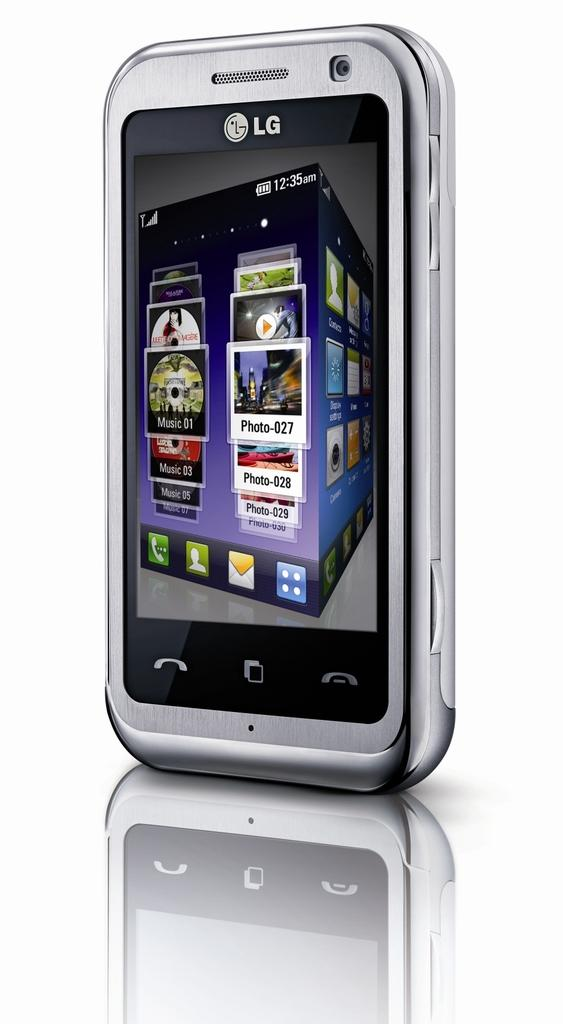<image>
Summarize the visual content of the image. an LG phone displaying the home screen with all the apps. 